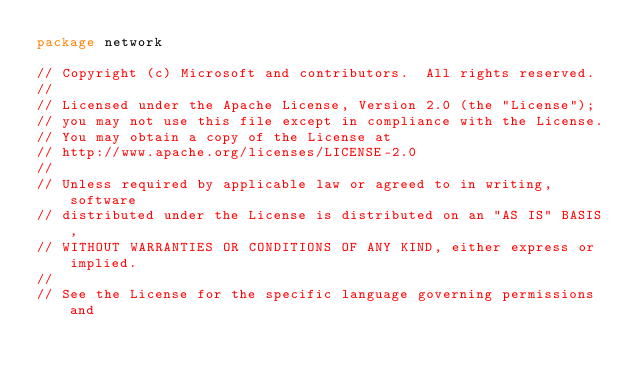Convert code to text. <code><loc_0><loc_0><loc_500><loc_500><_Go_>package network

// Copyright (c) Microsoft and contributors.  All rights reserved.
//
// Licensed under the Apache License, Version 2.0 (the "License");
// you may not use this file except in compliance with the License.
// You may obtain a copy of the License at
// http://www.apache.org/licenses/LICENSE-2.0
//
// Unless required by applicable law or agreed to in writing, software
// distributed under the License is distributed on an "AS IS" BASIS,
// WITHOUT WARRANTIES OR CONDITIONS OF ANY KIND, either express or implied.
//
// See the License for the specific language governing permissions and</code> 